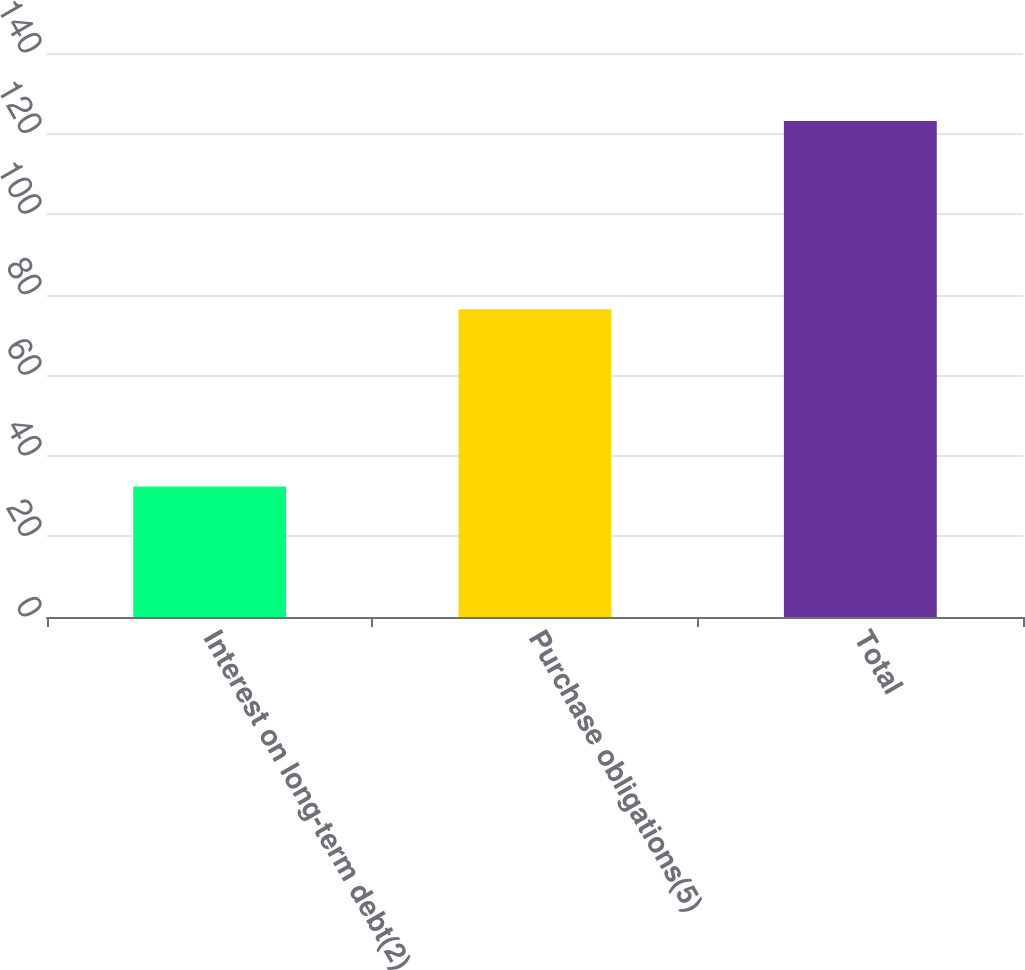Convert chart. <chart><loc_0><loc_0><loc_500><loc_500><bar_chart><fcel>Interest on long-term debt(2)<fcel>Purchase obligations(5)<fcel>Total<nl><fcel>32.4<fcel>76.4<fcel>123.1<nl></chart> 